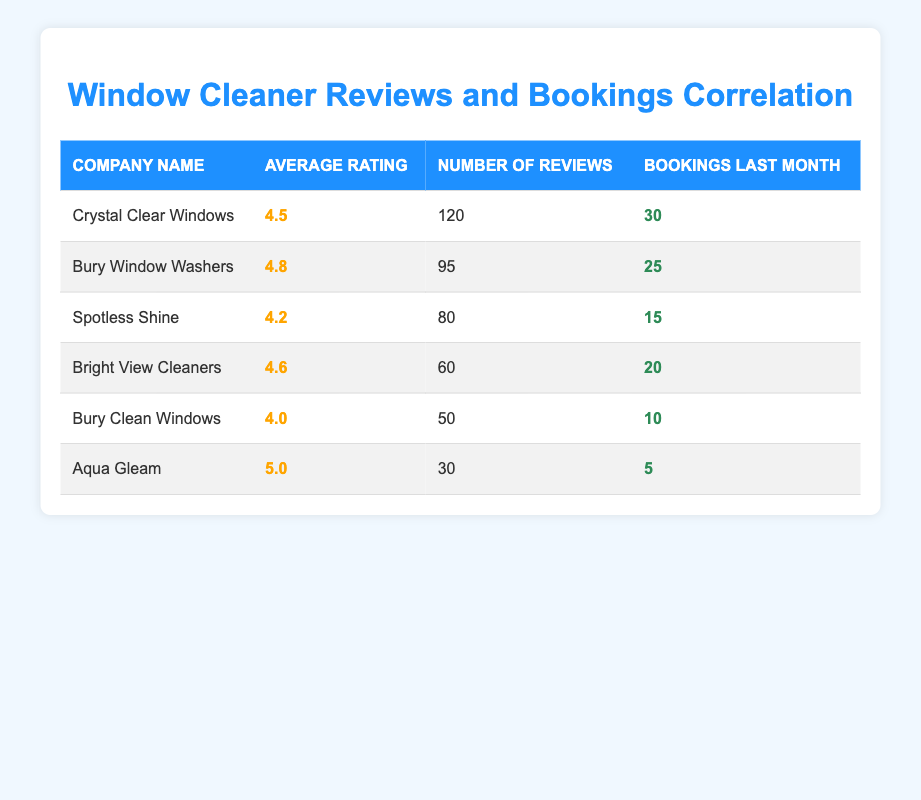What is the average rating of Bury Window Washers? The average rating for Bury Window Washers, as listed in the table, is 4.8.
Answer: 4.8 How many total bookings were made by all window cleaners last month? To find the total bookings, we add the bookings for each cleaner: 30 + 25 + 15 + 20 + 10 + 5 = 105.
Answer: 105 Is Crystal Clear Windows rated higher than Bury Clean Windows? Crystal Clear Windows has an average rating of 4.5, while Bury Clean Windows has a rating of 4.0; therefore, Crystal Clear Windows is rated higher.
Answer: Yes How many reviews did Spotless Shine have compared to Aqua Gleam? Spotless Shine has 80 reviews and Aqua Gleam has 30 reviews. The difference is 80 - 30 = 50 reviews; Spotless Shine has more reviews.
Answer: 50 Which window cleaner had the most bookings relative to the number of reviews? To determine this, we divide the bookings by the number of reviews for each cleaner: Crystal Clear Windows (30/120), Bury Window Washers (25/95), Spotless Shine (15/80), Bright View Cleaners (20/60), Bury Clean Windows (10/50), Aqua Gleam (5/30). Calculating these gives ratios: 0.25, 0.263, 0.1875, 0.333, 0.2, 0.1667 respectively. Bright View Cleaners has the highest ratio of bookings to reviews at 0.333.
Answer: Bright View Cleaners What is the correlation between the average rating and the number of bookings? To assess correlation, we observe trends: higher ratings (like 4.8 for Bury Window Washers) correlate with relatively high bookings (25), and lower ratings correlate with fewer bookings (like 4.0 for Bury Clean Windows with 10). Therefore, we can conclude there is a positive correlation between higher ratings and more bookings.
Answer: Positive correlation 